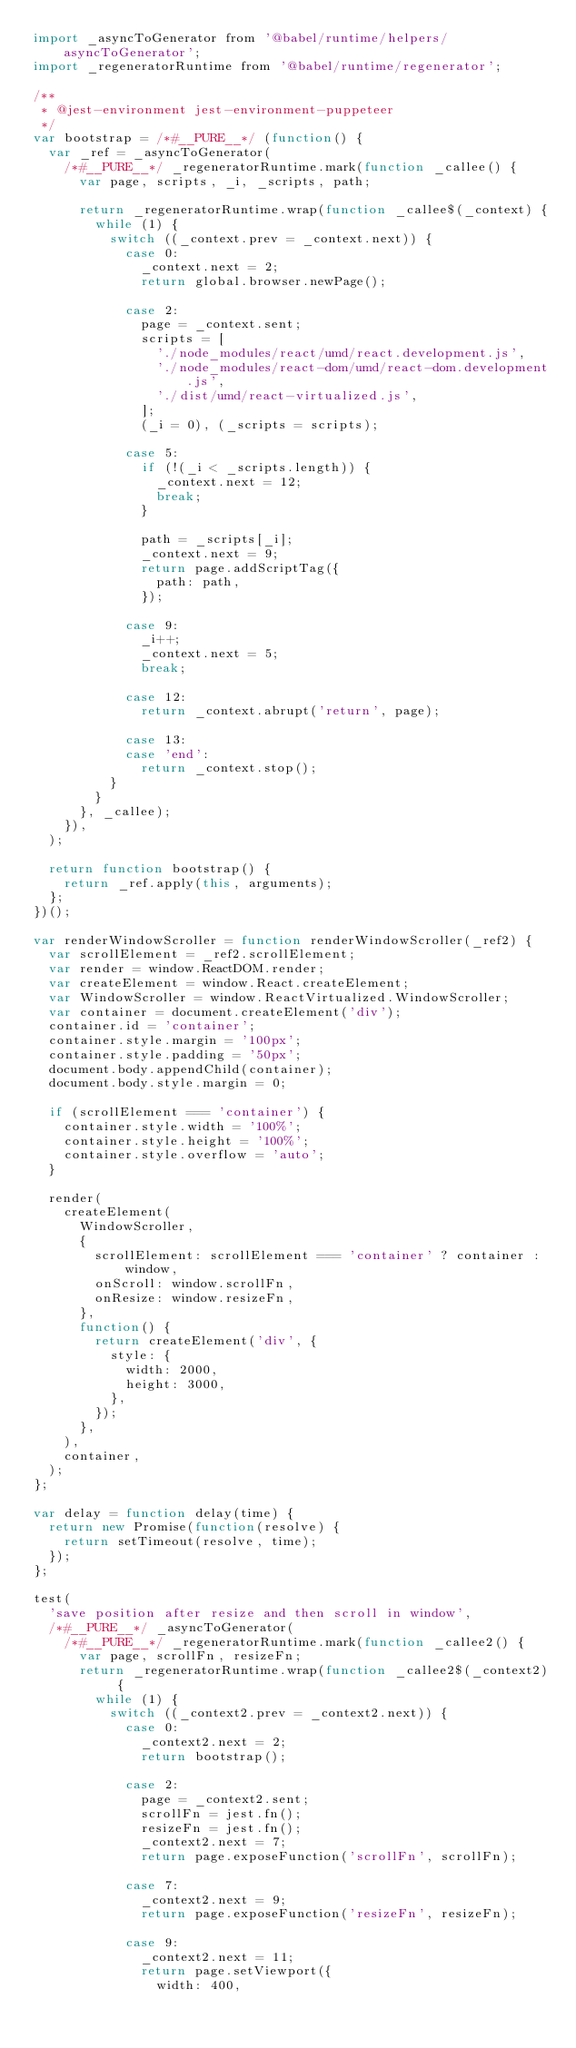Convert code to text. <code><loc_0><loc_0><loc_500><loc_500><_JavaScript_>import _asyncToGenerator from '@babel/runtime/helpers/asyncToGenerator';
import _regeneratorRuntime from '@babel/runtime/regenerator';

/**
 * @jest-environment jest-environment-puppeteer
 */
var bootstrap = /*#__PURE__*/ (function() {
  var _ref = _asyncToGenerator(
    /*#__PURE__*/ _regeneratorRuntime.mark(function _callee() {
      var page, scripts, _i, _scripts, path;

      return _regeneratorRuntime.wrap(function _callee$(_context) {
        while (1) {
          switch ((_context.prev = _context.next)) {
            case 0:
              _context.next = 2;
              return global.browser.newPage();

            case 2:
              page = _context.sent;
              scripts = [
                './node_modules/react/umd/react.development.js',
                './node_modules/react-dom/umd/react-dom.development.js',
                './dist/umd/react-virtualized.js',
              ];
              (_i = 0), (_scripts = scripts);

            case 5:
              if (!(_i < _scripts.length)) {
                _context.next = 12;
                break;
              }

              path = _scripts[_i];
              _context.next = 9;
              return page.addScriptTag({
                path: path,
              });

            case 9:
              _i++;
              _context.next = 5;
              break;

            case 12:
              return _context.abrupt('return', page);

            case 13:
            case 'end':
              return _context.stop();
          }
        }
      }, _callee);
    }),
  );

  return function bootstrap() {
    return _ref.apply(this, arguments);
  };
})();

var renderWindowScroller = function renderWindowScroller(_ref2) {
  var scrollElement = _ref2.scrollElement;
  var render = window.ReactDOM.render;
  var createElement = window.React.createElement;
  var WindowScroller = window.ReactVirtualized.WindowScroller;
  var container = document.createElement('div');
  container.id = 'container';
  container.style.margin = '100px';
  container.style.padding = '50px';
  document.body.appendChild(container);
  document.body.style.margin = 0;

  if (scrollElement === 'container') {
    container.style.width = '100%';
    container.style.height = '100%';
    container.style.overflow = 'auto';
  }

  render(
    createElement(
      WindowScroller,
      {
        scrollElement: scrollElement === 'container' ? container : window,
        onScroll: window.scrollFn,
        onResize: window.resizeFn,
      },
      function() {
        return createElement('div', {
          style: {
            width: 2000,
            height: 3000,
          },
        });
      },
    ),
    container,
  );
};

var delay = function delay(time) {
  return new Promise(function(resolve) {
    return setTimeout(resolve, time);
  });
};

test(
  'save position after resize and then scroll in window',
  /*#__PURE__*/ _asyncToGenerator(
    /*#__PURE__*/ _regeneratorRuntime.mark(function _callee2() {
      var page, scrollFn, resizeFn;
      return _regeneratorRuntime.wrap(function _callee2$(_context2) {
        while (1) {
          switch ((_context2.prev = _context2.next)) {
            case 0:
              _context2.next = 2;
              return bootstrap();

            case 2:
              page = _context2.sent;
              scrollFn = jest.fn();
              resizeFn = jest.fn();
              _context2.next = 7;
              return page.exposeFunction('scrollFn', scrollFn);

            case 7:
              _context2.next = 9;
              return page.exposeFunction('resizeFn', resizeFn);

            case 9:
              _context2.next = 11;
              return page.setViewport({
                width: 400,</code> 